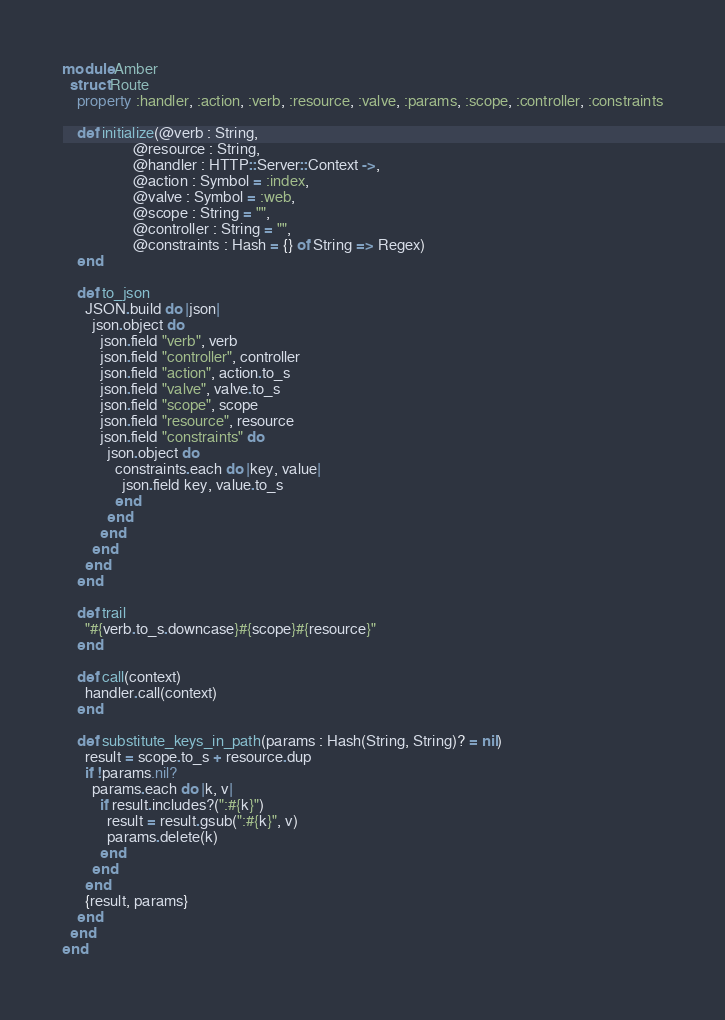<code> <loc_0><loc_0><loc_500><loc_500><_Crystal_>module Amber
  struct Route
    property :handler, :action, :verb, :resource, :valve, :params, :scope, :controller, :constraints

    def initialize(@verb : String,
                   @resource : String,
                   @handler : HTTP::Server::Context ->,
                   @action : Symbol = :index,
                   @valve : Symbol = :web,
                   @scope : String = "",
                   @controller : String = "",
                   @constraints : Hash = {} of String => Regex)
    end

    def to_json
      JSON.build do |json|
        json.object do
          json.field "verb", verb
          json.field "controller", controller
          json.field "action", action.to_s
          json.field "valve", valve.to_s
          json.field "scope", scope
          json.field "resource", resource
          json.field "constraints" do
            json.object do
              constraints.each do |key, value|
                json.field key, value.to_s
              end
            end
          end
        end
      end
    end

    def trail
      "#{verb.to_s.downcase}#{scope}#{resource}"
    end

    def call(context)
      handler.call(context)
    end

    def substitute_keys_in_path(params : Hash(String, String)? = nil)
      result = scope.to_s + resource.dup
      if !params.nil?
        params.each do |k, v|
          if result.includes?(":#{k}")
            result = result.gsub(":#{k}", v)
            params.delete(k)
          end
        end
      end
      {result, params}
    end
  end
end
</code> 